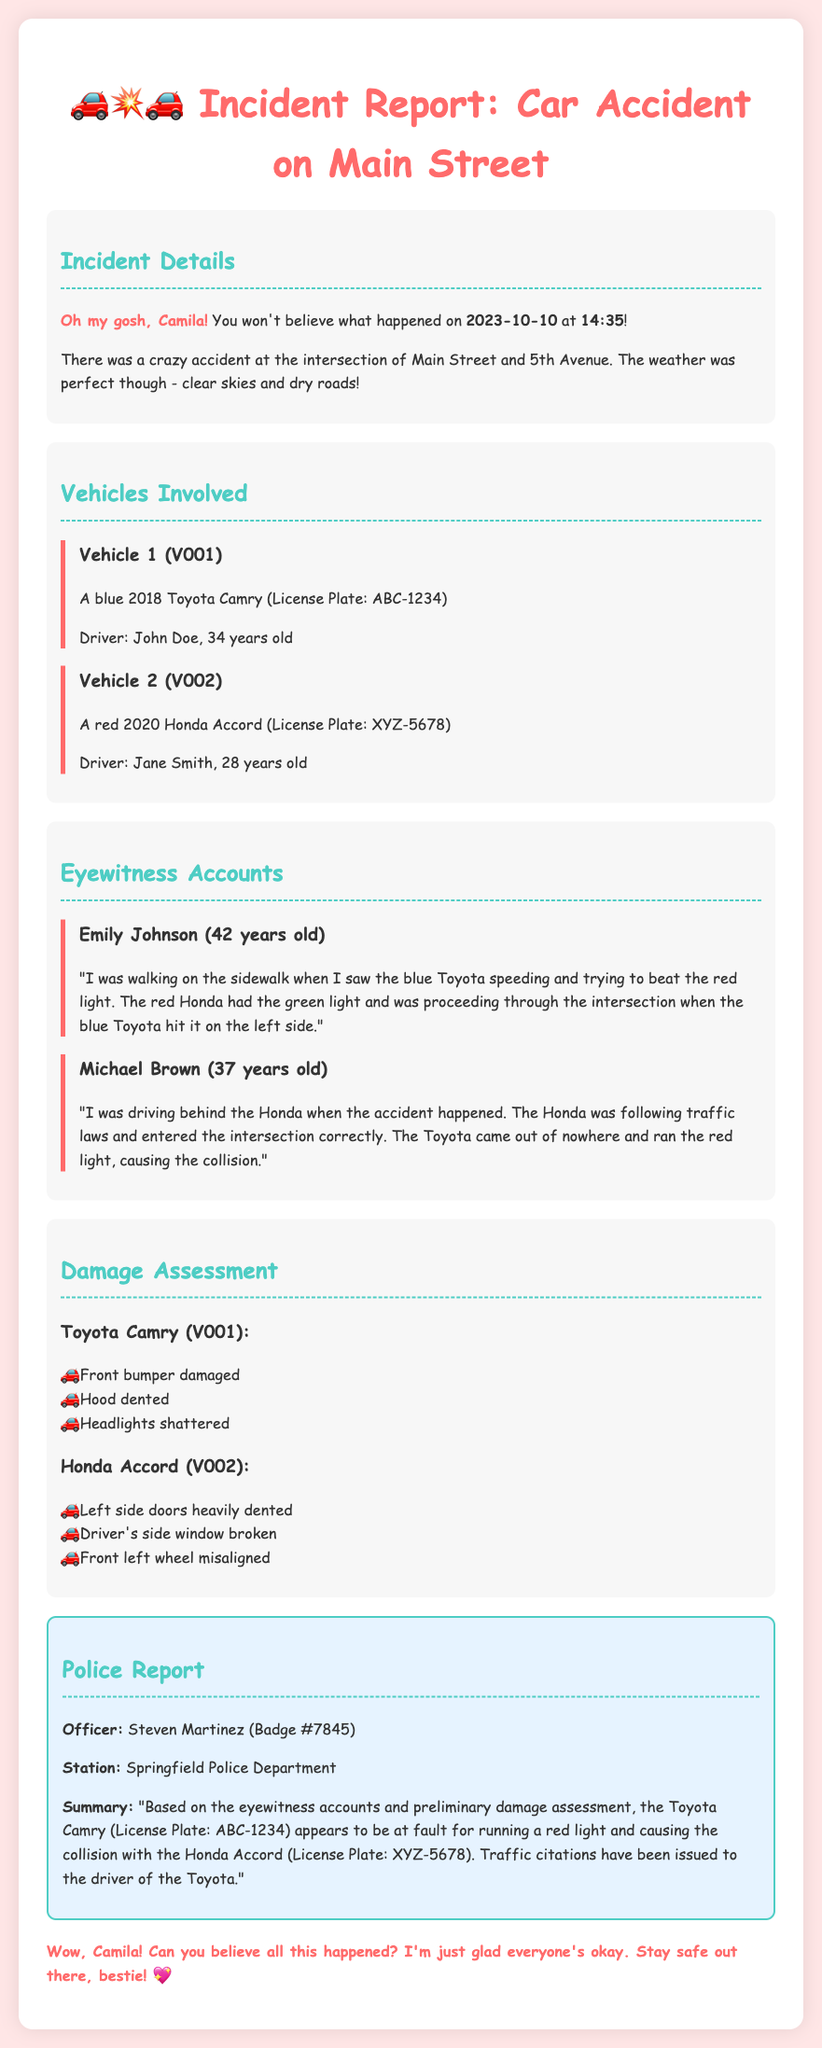what date did the accident occur? The accident occurred on the date specified in the document, which is 2023-10-10.
Answer: 2023-10-10 who was the driver of the blue Toyota Camry? The document states that the driver of the blue Toyota Camry is John Doe.
Answer: John Doe what type of vehicle was involved in the accident alongside the Toyota Camry? The document mentions a red Honda Accord was involved alongside the Toyota Camry.
Answer: red Honda Accord how many eyewitness accounts are included in the report? The report includes two eyewitness accounts from Emily Johnson and Michael Brown.
Answer: two what specific traffic violation did the Toyota Camry commit? According to the police report, the Toyota Camry ran a red light, which is the traffic violation committed.
Answer: ran a red light which side of the Honda Accord was damaged? The damage assessment shows that the left side doors of the Honda Accord were heavily dented.
Answer: left side who issued traffic citations to the driver of the Toyota? The police report states that Officer Steven Martinez issued traffic citations.
Answer: Officer Steven Martinez how old is the driver of the red Honda Accord? The document indicates that the driver of the red Honda Accord, Jane Smith, is 28 years old.
Answer: 28 years old 